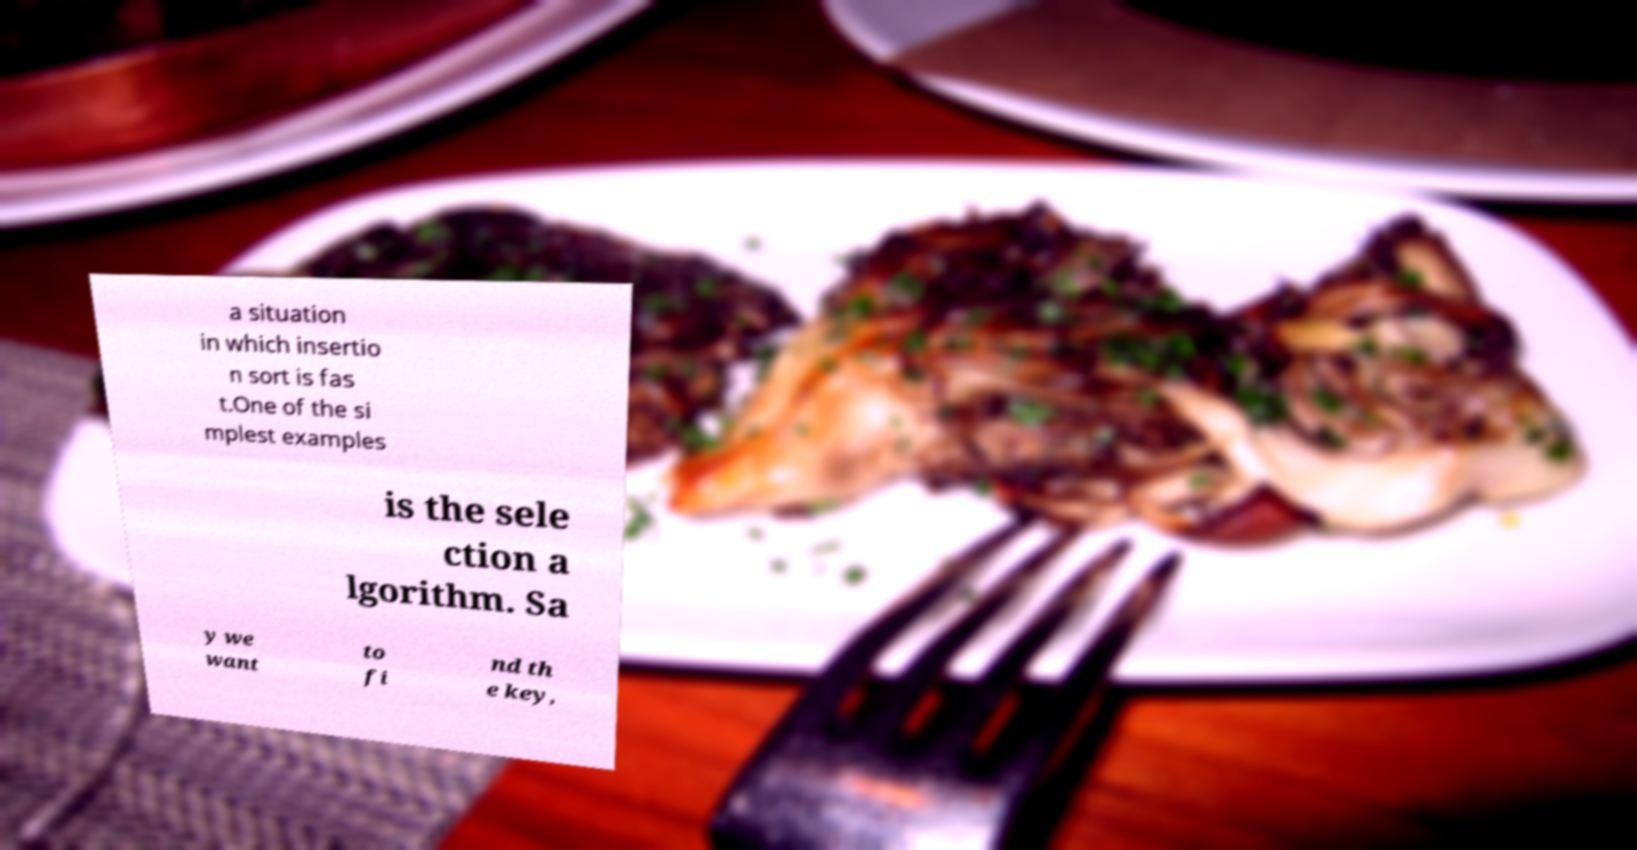For documentation purposes, I need the text within this image transcribed. Could you provide that? a situation in which insertio n sort is fas t.One of the si mplest examples is the sele ction a lgorithm. Sa y we want to fi nd th e key, 